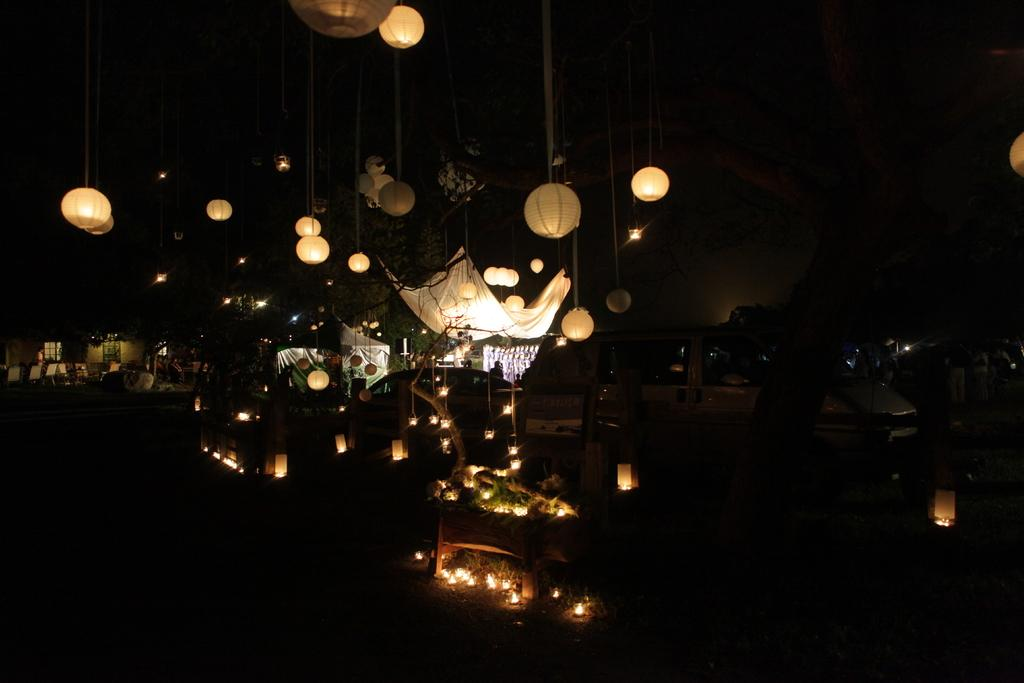What type of lighting is present in the image? There are lanterns in the image. What type of material is visible in the image? There is cloth in the image. What type of shelter is present in the image? There is a tent in the image. What type of vehicle is present in the image? There is a car in the image. Who is present in the image? A person is standing in the image. What type of structure is present in the image? There is a building in the image. What type of furniture is present in the image? There are chairs in the image. What architectural feature is present in the image? There is a window in the image. How would you describe the lighting conditions in the image? The background of the image is dark. What type of activity is the actor performing in the image? There is no actor present in the image, and therefore no activity can be observed. What type of sport is being played in the image? There is no sport or baseball present in the image. 